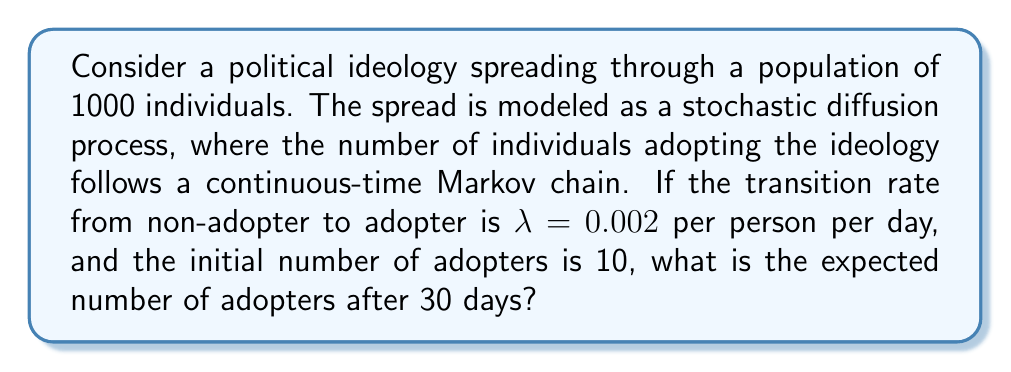Give your solution to this math problem. To solve this problem, we'll use the logistic growth model for the spread of ideas, which is a common approach in modeling the diffusion of innovations or ideologies.

Step 1: Identify the model
The logistic growth model for the expected number of adopters $E[X(t)]$ at time $t$ is given by:

$$E[X(t)] = \frac{N}{1 + (\frac{N}{X_0} - 1)e^{-\lambda Nt}}$$

Where:
$N$ is the total population
$X_0$ is the initial number of adopters
$\lambda$ is the transition rate
$t$ is the time

Step 2: Plug in the given values
$N = 1000$ (total population)
$X_0 = 10$ (initial adopters)
$\lambda = 0.002$ (transition rate per person per day)
$t = 30$ (days)

Step 3: Calculate the expected number of adopters
$$E[X(30)] = \frac{1000}{1 + (\frac{1000}{10} - 1)e^{-0.002 \cdot 1000 \cdot 30}}$$

Step 4: Simplify the expression
$$E[X(30)] = \frac{1000}{1 + 99e^{-60}}$$

Step 5: Calculate the final result
Using a calculator or computer, we can evaluate this expression:

$$E[X(30)] \approx 403.43$$

Step 6: Round to the nearest whole number
Since we're dealing with individuals, we round to the nearest integer:

$$E[X(30)] \approx 403$$

Therefore, the expected number of adopters after 30 days is approximately 403 individuals.
Answer: 403 